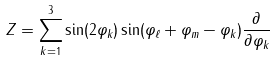<formula> <loc_0><loc_0><loc_500><loc_500>Z = \sum ^ { 3 } _ { k = 1 } \sin ( 2 \varphi _ { k } ) \sin ( \varphi _ { \ell } + \varphi _ { m } - \varphi _ { k } ) \frac { \partial } { \partial \varphi _ { k } }</formula> 